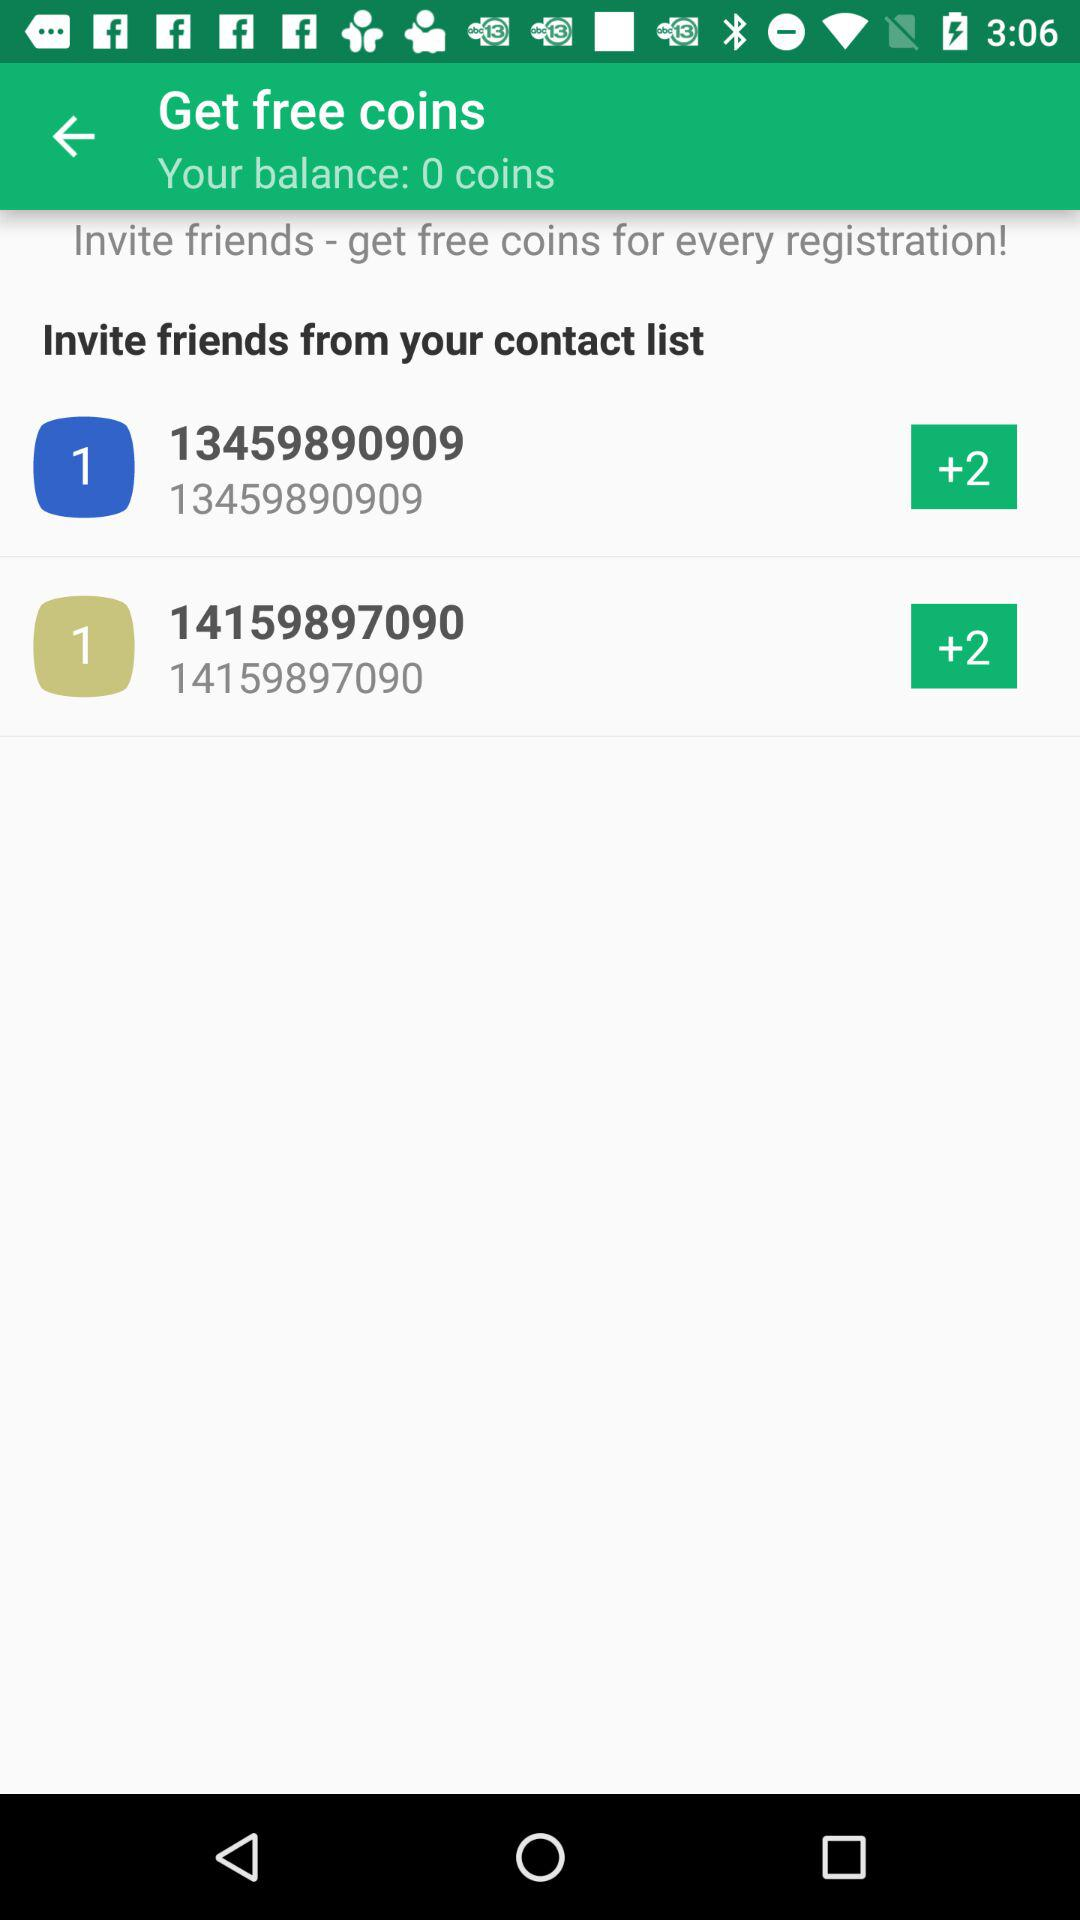How many coins do you have?
Answer the question using a single word or phrase. 0 